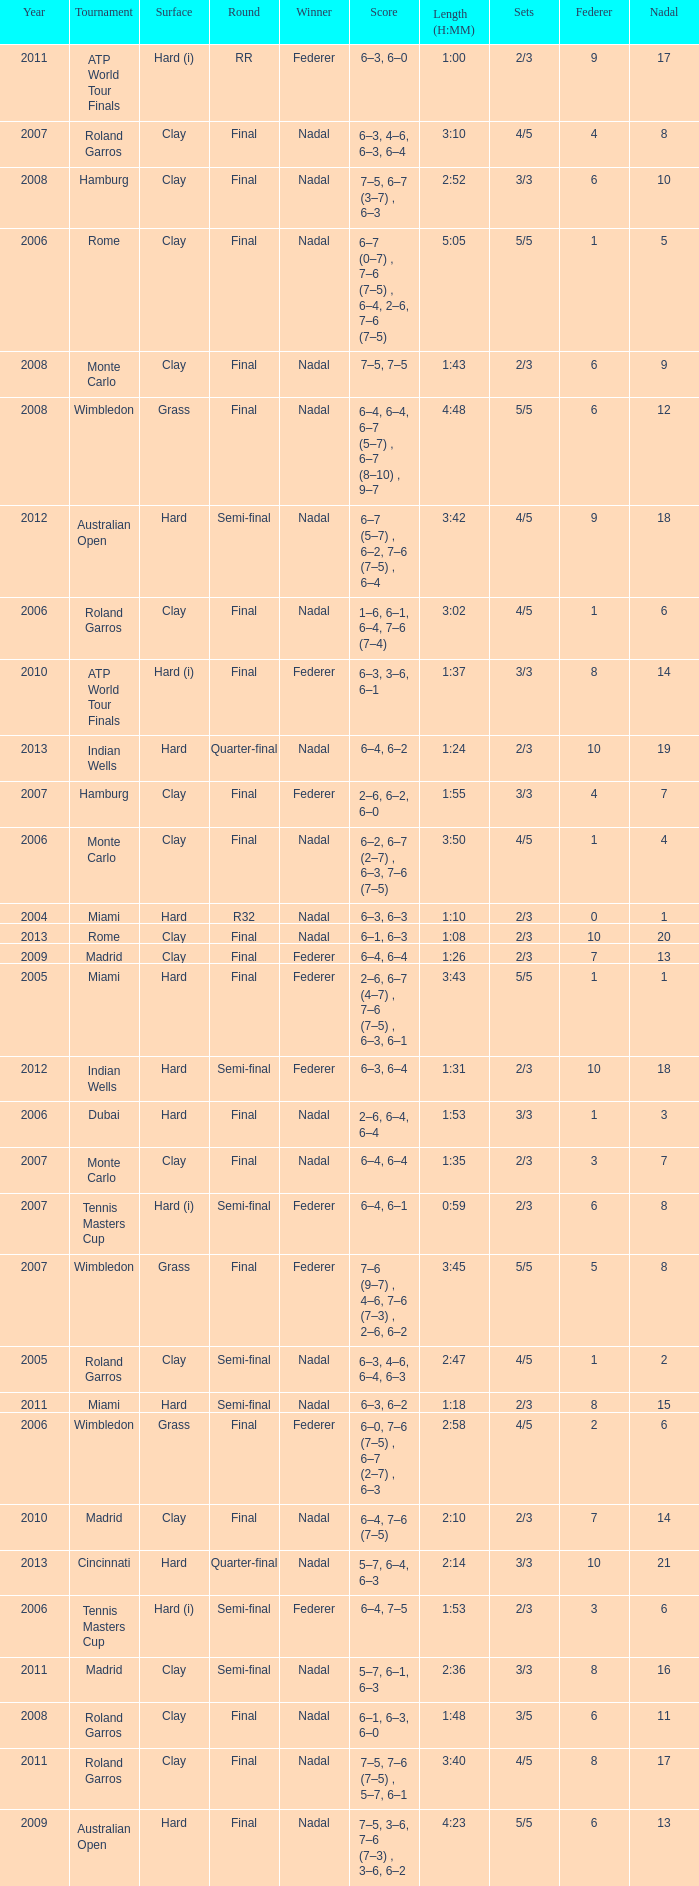What were the sets when Federer had 6 and a nadal of 13? 5/5. 